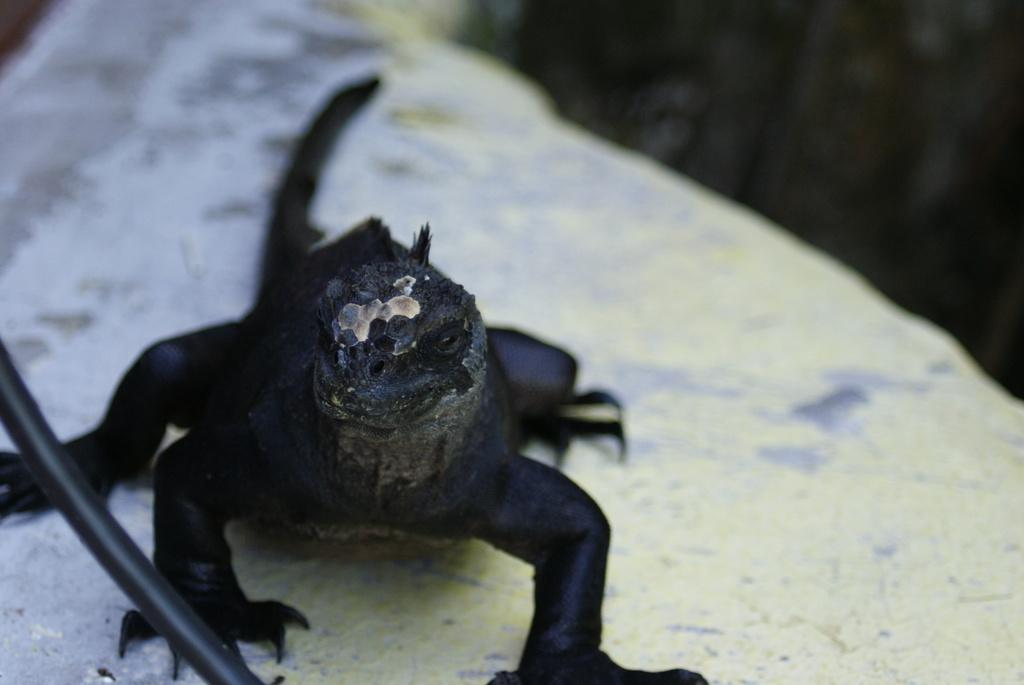What type of animal is present in the image? There is a black color reptile in the image. How many sheep can be seen grazing near the border in the image? There are no sheep or borders present in the image; it features a black color reptile. What recent discovery was made by the reptile in the image? There is no indication of a recent discovery in the image, as it only shows a reptile. 